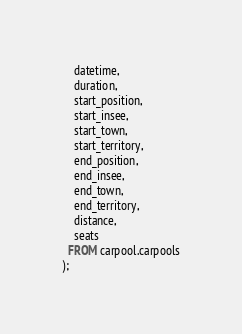Convert code to text. <code><loc_0><loc_0><loc_500><loc_500><_SQL_>    datetime,
    duration,
    start_position,
    start_insee,
    start_town,
    start_territory,
    end_position,
    end_insee,
    end_town,
    end_territory,
    distance,
    seats
  FROM carpool.carpools
);
</code> 